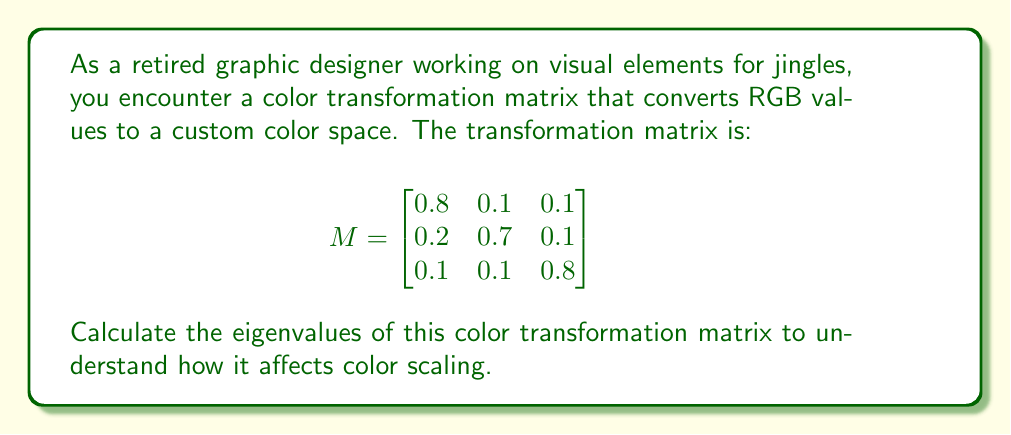Give your solution to this math problem. To find the eigenvalues of the matrix M, we need to solve the characteristic equation:

$$\det(M - \lambda I) = 0$$

where $\lambda$ represents the eigenvalues and I is the 3x3 identity matrix.

Step 1: Set up the characteristic equation:

$$
\det\begin{pmatrix}
0.8 - \lambda & 0.1 & 0.1 \\
0.2 & 0.7 - \lambda & 0.1 \\
0.1 & 0.1 & 0.8 - \lambda
\end{pmatrix} = 0
$$

Step 2: Expand the determinant:

$$(0.8 - \lambda)[(0.7 - \lambda)(0.8 - \lambda) - 0.01] - 0.1[0.2(0.8 - \lambda) - 0.1(0.1)] + 0.1[0.2(0.1) - 0.1(0.7 - \lambda)] = 0$$

Step 3: Simplify:

$$(\lambda - 1)(\lambda - 0.7)(\lambda - 0.6) = 0$$

Step 4: Solve for $\lambda$:

The eigenvalues are the roots of this cubic equation:

$\lambda_1 = 1$
$\lambda_2 = 0.7$
$\lambda_3 = 0.6$
Answer: $\lambda_1 = 1$, $\lambda_2 = 0.7$, $\lambda_3 = 0.6$ 